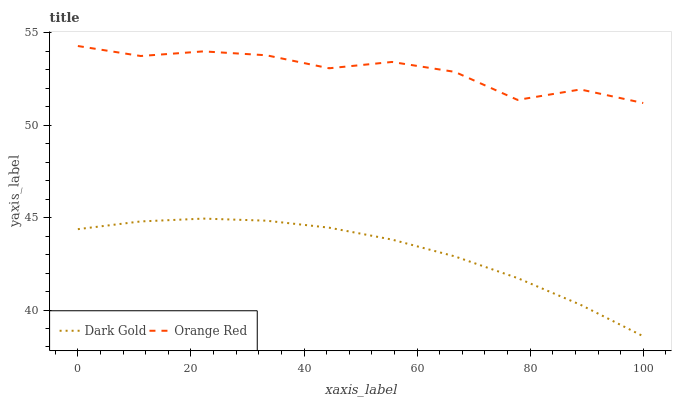Does Dark Gold have the minimum area under the curve?
Answer yes or no. Yes. Does Orange Red have the maximum area under the curve?
Answer yes or no. Yes. Does Dark Gold have the maximum area under the curve?
Answer yes or no. No. Is Dark Gold the smoothest?
Answer yes or no. Yes. Is Orange Red the roughest?
Answer yes or no. Yes. Is Dark Gold the roughest?
Answer yes or no. No. Does Dark Gold have the lowest value?
Answer yes or no. Yes. Does Orange Red have the highest value?
Answer yes or no. Yes. Does Dark Gold have the highest value?
Answer yes or no. No. Is Dark Gold less than Orange Red?
Answer yes or no. Yes. Is Orange Red greater than Dark Gold?
Answer yes or no. Yes. Does Dark Gold intersect Orange Red?
Answer yes or no. No. 